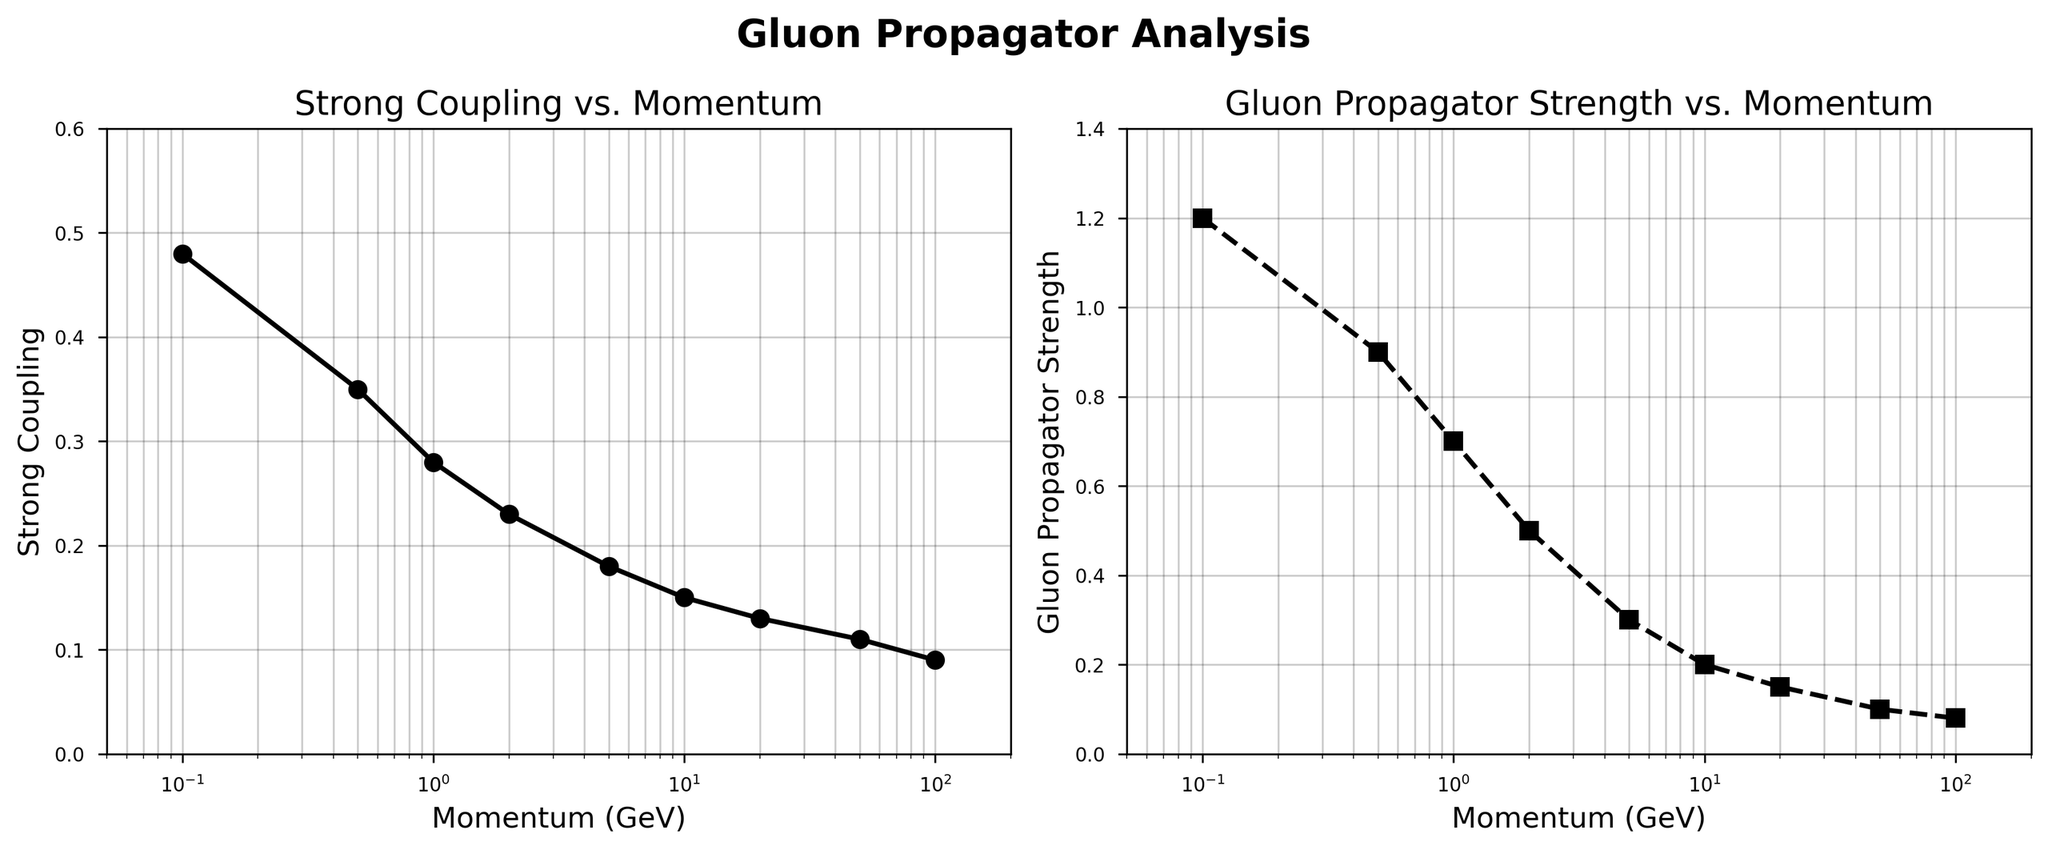What's the title of the first subplot? The title is located directly above the first subplot. It reads "Strong Coupling vs. Momentum".
Answer: Strong Coupling vs. Momentum What is the approximate Strong Coupling value at a momentum of 5.0 GeV? Locate the point on the Strong Coupling vs. Momentum plot where the Momentum is 5.0 GeV. The corresponding Strong Coupling value is around 0.18.
Answer: 0.18 How does the Gluon Propagator Strength change as momentum increases from 0.1 GeV to 100.0 GeV? On the second subplot, observe the trend of the Gluon Propagator Strength from 0.1 GeV to 100.0 GeV. It gradually decreases from 1.2 to 0.08.
Answer: It decreases Which subplot uses dashed lines to represent data points? Examine the line styles used in both subplots. The second subplot (Gluon Propagator Strength vs. Momentum) uses dashed lines.
Answer: The second subplot What's the difference between the Gluon Propagator Strength at 0.1 GeV and 100.0 GeV? Identify the values from the second subplot: Gluon Propagator Strength is 1.2 at 0.1 GeV and 0.08 at 100.0 GeV. The difference is 1.2 - 0.08.
Answer: 1.12 Which parameter exhibits a steeper decline with increasing momentum up to 10.0 GeV? Compare the slopes of the curves in both subplots from 0.1 GeV to 10.0 GeV. The Strong Coupling curve exhibits a steeper decline.
Answer: Strong Coupling At what momentum does the Gluon Propagator Strength drop below 0.5? Identify the downward trend in the second subplot and find the momentum value where the Gluon Propagator Strength is just below 0.5. It is at approximately 2.0 GeV.
Answer: 2.0 GeV What’s the y-axis label of the second subplot? The y-axis label is found on the left side of the second subplot. It reads "Gluon Propagator Strength".
Answer: Gluon Propagator Strength By what factor does the Strong Coupling reduce as momentum increases from 0.5 GeV to 10.0 GeV? Find the Strong Coupling values at 0.5 GeV (0.35) and 10.0 GeV (0.15). The reduction factor is calculated as 0.35 / 0.15.
Answer: Approximately 2.33 What is the approximate ratio of the Strong Coupling to Gluon Propagator Strength at 0.1 GeV? Find the values at 0.1 GeV. Strong Coupling is 0.48 and Gluon Propagator Strength is 1.2. The ratio is 0.48 / 1.2.
Answer: 0.4 